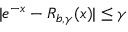Convert formula to latex. <formula><loc_0><loc_0><loc_500><loc_500>| e ^ { - x } - R _ { b , \gamma } ( x ) | \leq \gamma</formula> 